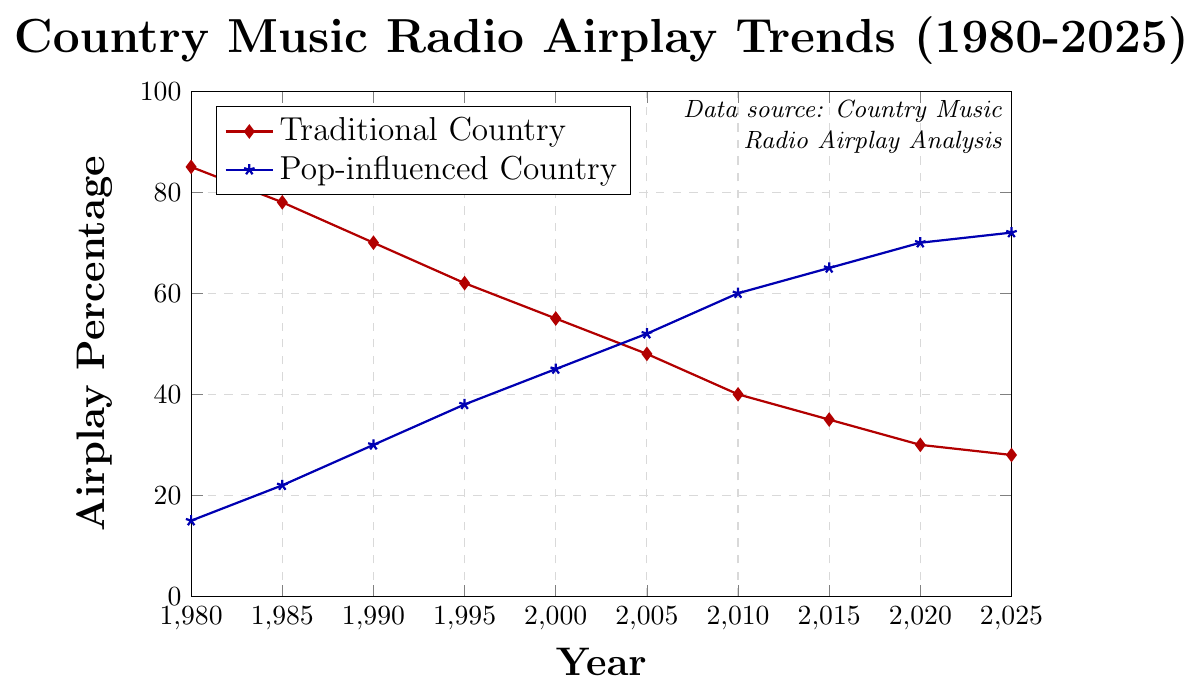What was the percentage of traditional country airplay in 1980? The data point for traditional country airplay in 1980 is marked where it intersects the "Traditional Country" line at around 85%.
Answer: 85% What's the difference in airplay percentage between traditional country and pop-influenced country in 1990? The percentage for traditional country in 1990 is 70%, and for pop-influenced country, it is 30%. The difference is 70% - 30%.
Answer: 40% Which genre of country music saw a higher percentage increase in airplay from 1980 to 2020? Traditional country decreased from 85% to 30%, and pop-influenced country increased from 15% to 70%. Difference for pop-influenced is 70% - 15% = 55%, and traditional's change is 85% - 30% = 55%. Both saw a change, but pop-influenced increased.
Answer: Pop-influenced Country In which year did pop-influenced country first surpass traditional country in airplay? Pop-influenced first surpasses traditional country between 2000 and 2005. The specific data point shows pop-influenced airplay at 52% in 2005 versus traditional's 48%.
Answer: 2005 What is the trend of traditional country airplay from 1980 to 2025? Over the timeline from 1980 to 2025, the traditional country airplay line consistently declines from 85% to 28%.
Answer: Declining In which year was the airplay percentage for traditional country exactly half of what it was in 1985? In 1985, traditional country airplay was 78%. Half of 78% is 39%. In 2010, it can be observed that traditional country airplay was approximately 40%.
Answer: 2010 How does the peak airplay percentage of traditional country in 1980 compare to its lowest airplay percentage in 2025? Traditional country had its highest airplay at 85% in 1980 and its lowest at 28% in 2025. The comparison shows a substantial decrease.
Answer: 85% vs. 28% What's the overall trend for pop-influenced country airplay from 1980 to 2025? From the figure, the line representing pop-influenced country rises steadily from 15% in 1980 to 72% in 2025.
Answer: Rising Based on the trends, what is the expected airplay percentage difference for the two genres in 2025? For 2025, traditional country is at 28%, and pop-influenced is at 72%. The difference is 72% - 28%.
Answer: 44% 